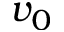Convert formula to latex. <formula><loc_0><loc_0><loc_500><loc_500>v _ { 0 }</formula> 